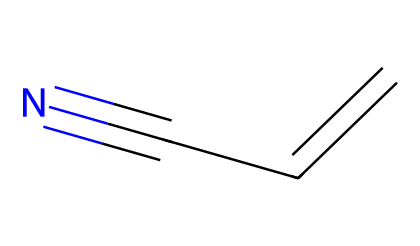What is the molecular formula of acrylonitrile? The SMILES representation consists of three carbon atoms, one nitrogen atom, and a hydrogen count derived from the discrepancy between carbon and hydrogen bonding, resulting in the formula C3H3N.
Answer: C3H3N How many carbon atoms are present in acrylonitrile? The visual representation shows three 'C' symbols, indicating the presence of three carbon atoms in the molecule.
Answer: 3 What type of bond is present between the carbon atoms in acrylonitrile? The SMILES indicates a double bond between the first two carbon atoms (C=C), indicating a double bond type in the structural formula.
Answer: double bond How many hydrogen atoms are attached to the carbon atoms in acrylonitrile? By deducing the valency of carbon (which is 4) and the structure of acrylonitrile, we see that two carbon atoms are involved in a double bond, leaving only three hydrogen atoms attached in total across the structure.
Answer: 3 What characteristic functional group does acrylonitrile contain? The presence of the 'CN' part in the SMILES indicates a nitrile functional group, which consists of a carbon atom triple-bonded to a nitrogen atom.
Answer: nitrile What is the primary use of acrylonitrile? Acrylonitrile is primarily used in the production of acrylic fibers, commonly found in clothing and textiles.
Answer: acrylic fibers How does the presence of the nitrile group affect the polarity of acrylonitrile? The nitrile group (C≡N) creates a polar functional group due to the significant electronegativity difference between carbon and nitrogen, which contributes to the overall polarity of the molecule.
Answer: polar 